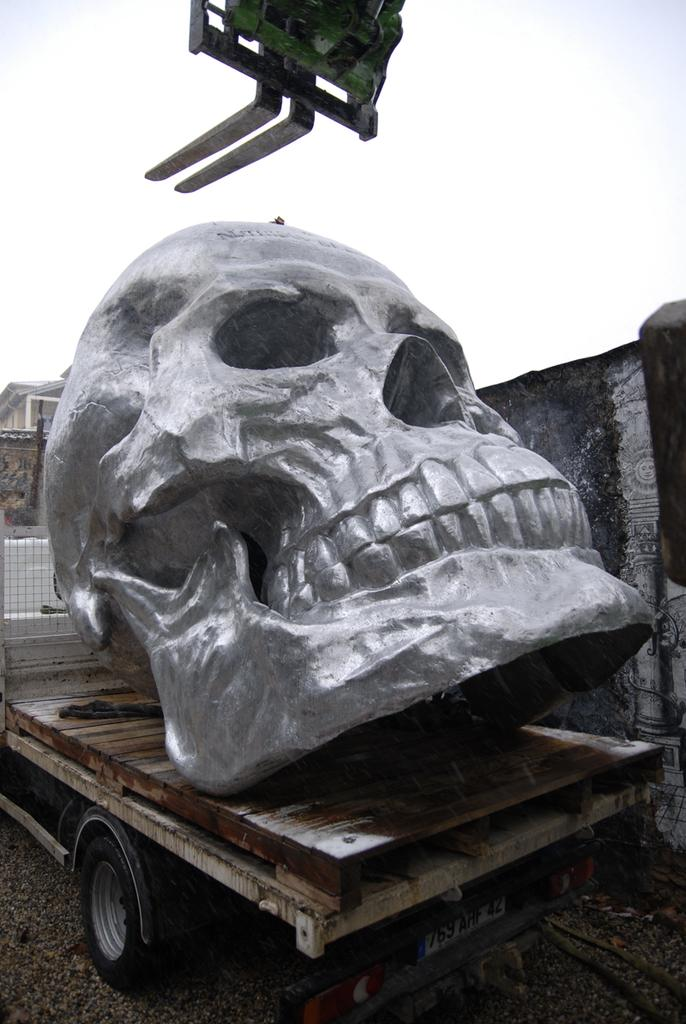What is the main subject of the image? The main subject of the image is a sculpture of a skull. Where is the skull sculpture placed? The sculpture is kept on a truck. What can be seen in the background of the image? There is a wall visible in the background of the image. How many brothers are depicted on the island in the image? There is no island or brothers present in the image; it features a skull sculpture on a truck with a wall in the background. What type of branch is growing from the skull sculpture in the image? There is no branch growing from the skull sculpture in the image. 